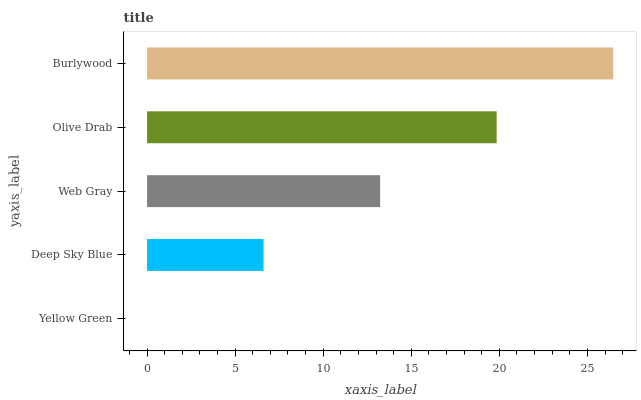Is Yellow Green the minimum?
Answer yes or no. Yes. Is Burlywood the maximum?
Answer yes or no. Yes. Is Deep Sky Blue the minimum?
Answer yes or no. No. Is Deep Sky Blue the maximum?
Answer yes or no. No. Is Deep Sky Blue greater than Yellow Green?
Answer yes or no. Yes. Is Yellow Green less than Deep Sky Blue?
Answer yes or no. Yes. Is Yellow Green greater than Deep Sky Blue?
Answer yes or no. No. Is Deep Sky Blue less than Yellow Green?
Answer yes or no. No. Is Web Gray the high median?
Answer yes or no. Yes. Is Web Gray the low median?
Answer yes or no. Yes. Is Olive Drab the high median?
Answer yes or no. No. Is Yellow Green the low median?
Answer yes or no. No. 